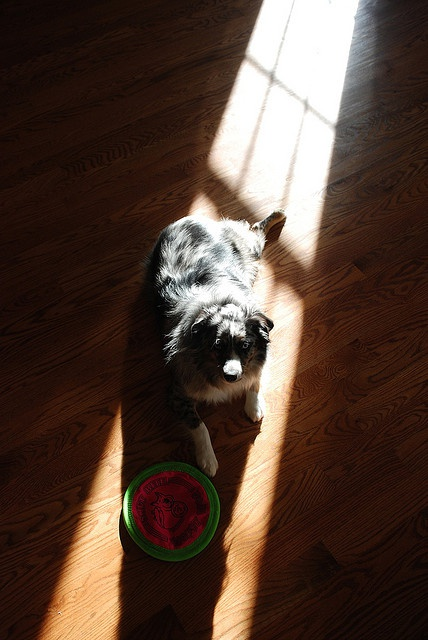Describe the objects in this image and their specific colors. I can see dog in black, white, darkgray, and gray tones and frisbee in black, maroon, darkgreen, and beige tones in this image. 